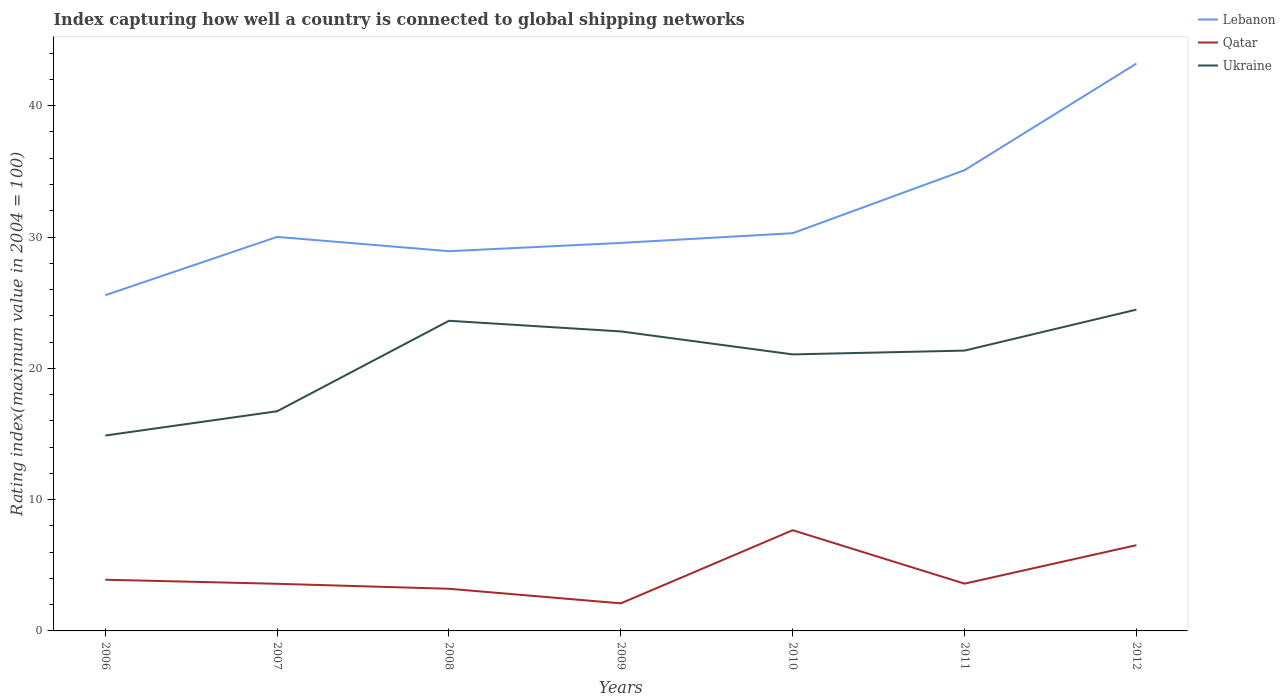How many different coloured lines are there?
Provide a short and direct response. 3. Across all years, what is the maximum rating index in Qatar?
Give a very brief answer. 2.1. What is the total rating index in Ukraine in the graph?
Offer a very short reply. -8.74. What is the difference between the highest and the second highest rating index in Ukraine?
Give a very brief answer. 9.59. How many years are there in the graph?
Your response must be concise. 7. What is the difference between two consecutive major ticks on the Y-axis?
Provide a succinct answer. 10. Are the values on the major ticks of Y-axis written in scientific E-notation?
Offer a terse response. No. How many legend labels are there?
Ensure brevity in your answer.  3. What is the title of the graph?
Give a very brief answer. Index capturing how well a country is connected to global shipping networks. What is the label or title of the Y-axis?
Ensure brevity in your answer.  Rating index(maximum value in 2004 = 100). What is the Rating index(maximum value in 2004 = 100) in Lebanon in 2006?
Offer a terse response. 25.57. What is the Rating index(maximum value in 2004 = 100) of Ukraine in 2006?
Offer a very short reply. 14.88. What is the Rating index(maximum value in 2004 = 100) of Lebanon in 2007?
Provide a succinct answer. 30.01. What is the Rating index(maximum value in 2004 = 100) in Qatar in 2007?
Offer a very short reply. 3.59. What is the Rating index(maximum value in 2004 = 100) of Ukraine in 2007?
Ensure brevity in your answer.  16.73. What is the Rating index(maximum value in 2004 = 100) of Lebanon in 2008?
Give a very brief answer. 28.92. What is the Rating index(maximum value in 2004 = 100) in Qatar in 2008?
Ensure brevity in your answer.  3.21. What is the Rating index(maximum value in 2004 = 100) in Ukraine in 2008?
Offer a very short reply. 23.62. What is the Rating index(maximum value in 2004 = 100) of Lebanon in 2009?
Provide a short and direct response. 29.55. What is the Rating index(maximum value in 2004 = 100) in Ukraine in 2009?
Make the answer very short. 22.81. What is the Rating index(maximum value in 2004 = 100) in Lebanon in 2010?
Give a very brief answer. 30.29. What is the Rating index(maximum value in 2004 = 100) of Qatar in 2010?
Your answer should be very brief. 7.67. What is the Rating index(maximum value in 2004 = 100) in Ukraine in 2010?
Provide a short and direct response. 21.06. What is the Rating index(maximum value in 2004 = 100) in Lebanon in 2011?
Offer a very short reply. 35.09. What is the Rating index(maximum value in 2004 = 100) in Qatar in 2011?
Ensure brevity in your answer.  3.6. What is the Rating index(maximum value in 2004 = 100) of Ukraine in 2011?
Your answer should be very brief. 21.35. What is the Rating index(maximum value in 2004 = 100) in Lebanon in 2012?
Offer a very short reply. 43.21. What is the Rating index(maximum value in 2004 = 100) of Qatar in 2012?
Your answer should be compact. 6.53. What is the Rating index(maximum value in 2004 = 100) in Ukraine in 2012?
Make the answer very short. 24.47. Across all years, what is the maximum Rating index(maximum value in 2004 = 100) in Lebanon?
Your answer should be very brief. 43.21. Across all years, what is the maximum Rating index(maximum value in 2004 = 100) in Qatar?
Your answer should be very brief. 7.67. Across all years, what is the maximum Rating index(maximum value in 2004 = 100) of Ukraine?
Offer a terse response. 24.47. Across all years, what is the minimum Rating index(maximum value in 2004 = 100) in Lebanon?
Keep it short and to the point. 25.57. Across all years, what is the minimum Rating index(maximum value in 2004 = 100) of Ukraine?
Provide a succinct answer. 14.88. What is the total Rating index(maximum value in 2004 = 100) of Lebanon in the graph?
Keep it short and to the point. 222.64. What is the total Rating index(maximum value in 2004 = 100) in Qatar in the graph?
Make the answer very short. 30.6. What is the total Rating index(maximum value in 2004 = 100) in Ukraine in the graph?
Make the answer very short. 144.92. What is the difference between the Rating index(maximum value in 2004 = 100) of Lebanon in 2006 and that in 2007?
Ensure brevity in your answer.  -4.44. What is the difference between the Rating index(maximum value in 2004 = 100) in Qatar in 2006 and that in 2007?
Give a very brief answer. 0.31. What is the difference between the Rating index(maximum value in 2004 = 100) in Ukraine in 2006 and that in 2007?
Offer a very short reply. -1.85. What is the difference between the Rating index(maximum value in 2004 = 100) of Lebanon in 2006 and that in 2008?
Provide a short and direct response. -3.35. What is the difference between the Rating index(maximum value in 2004 = 100) of Qatar in 2006 and that in 2008?
Your answer should be very brief. 0.69. What is the difference between the Rating index(maximum value in 2004 = 100) of Ukraine in 2006 and that in 2008?
Your response must be concise. -8.74. What is the difference between the Rating index(maximum value in 2004 = 100) of Lebanon in 2006 and that in 2009?
Offer a very short reply. -3.98. What is the difference between the Rating index(maximum value in 2004 = 100) in Ukraine in 2006 and that in 2009?
Make the answer very short. -7.93. What is the difference between the Rating index(maximum value in 2004 = 100) of Lebanon in 2006 and that in 2010?
Provide a succinct answer. -4.72. What is the difference between the Rating index(maximum value in 2004 = 100) of Qatar in 2006 and that in 2010?
Provide a short and direct response. -3.77. What is the difference between the Rating index(maximum value in 2004 = 100) of Ukraine in 2006 and that in 2010?
Your answer should be compact. -6.18. What is the difference between the Rating index(maximum value in 2004 = 100) of Lebanon in 2006 and that in 2011?
Make the answer very short. -9.52. What is the difference between the Rating index(maximum value in 2004 = 100) of Ukraine in 2006 and that in 2011?
Give a very brief answer. -6.47. What is the difference between the Rating index(maximum value in 2004 = 100) of Lebanon in 2006 and that in 2012?
Your response must be concise. -17.64. What is the difference between the Rating index(maximum value in 2004 = 100) in Qatar in 2006 and that in 2012?
Your response must be concise. -2.63. What is the difference between the Rating index(maximum value in 2004 = 100) in Ukraine in 2006 and that in 2012?
Your answer should be very brief. -9.59. What is the difference between the Rating index(maximum value in 2004 = 100) in Lebanon in 2007 and that in 2008?
Offer a terse response. 1.09. What is the difference between the Rating index(maximum value in 2004 = 100) of Qatar in 2007 and that in 2008?
Provide a short and direct response. 0.38. What is the difference between the Rating index(maximum value in 2004 = 100) of Ukraine in 2007 and that in 2008?
Your answer should be very brief. -6.89. What is the difference between the Rating index(maximum value in 2004 = 100) of Lebanon in 2007 and that in 2009?
Ensure brevity in your answer.  0.46. What is the difference between the Rating index(maximum value in 2004 = 100) in Qatar in 2007 and that in 2009?
Give a very brief answer. 1.49. What is the difference between the Rating index(maximum value in 2004 = 100) in Ukraine in 2007 and that in 2009?
Your answer should be compact. -6.08. What is the difference between the Rating index(maximum value in 2004 = 100) in Lebanon in 2007 and that in 2010?
Give a very brief answer. -0.28. What is the difference between the Rating index(maximum value in 2004 = 100) of Qatar in 2007 and that in 2010?
Ensure brevity in your answer.  -4.08. What is the difference between the Rating index(maximum value in 2004 = 100) of Ukraine in 2007 and that in 2010?
Provide a succinct answer. -4.33. What is the difference between the Rating index(maximum value in 2004 = 100) in Lebanon in 2007 and that in 2011?
Provide a short and direct response. -5.08. What is the difference between the Rating index(maximum value in 2004 = 100) of Qatar in 2007 and that in 2011?
Keep it short and to the point. -0.01. What is the difference between the Rating index(maximum value in 2004 = 100) in Ukraine in 2007 and that in 2011?
Ensure brevity in your answer.  -4.62. What is the difference between the Rating index(maximum value in 2004 = 100) in Qatar in 2007 and that in 2012?
Give a very brief answer. -2.94. What is the difference between the Rating index(maximum value in 2004 = 100) of Ukraine in 2007 and that in 2012?
Your response must be concise. -7.74. What is the difference between the Rating index(maximum value in 2004 = 100) in Lebanon in 2008 and that in 2009?
Provide a succinct answer. -0.63. What is the difference between the Rating index(maximum value in 2004 = 100) in Qatar in 2008 and that in 2009?
Keep it short and to the point. 1.11. What is the difference between the Rating index(maximum value in 2004 = 100) of Ukraine in 2008 and that in 2009?
Your answer should be very brief. 0.81. What is the difference between the Rating index(maximum value in 2004 = 100) in Lebanon in 2008 and that in 2010?
Offer a very short reply. -1.37. What is the difference between the Rating index(maximum value in 2004 = 100) in Qatar in 2008 and that in 2010?
Provide a succinct answer. -4.46. What is the difference between the Rating index(maximum value in 2004 = 100) in Ukraine in 2008 and that in 2010?
Ensure brevity in your answer.  2.56. What is the difference between the Rating index(maximum value in 2004 = 100) of Lebanon in 2008 and that in 2011?
Your response must be concise. -6.17. What is the difference between the Rating index(maximum value in 2004 = 100) of Qatar in 2008 and that in 2011?
Your response must be concise. -0.39. What is the difference between the Rating index(maximum value in 2004 = 100) in Ukraine in 2008 and that in 2011?
Provide a succinct answer. 2.27. What is the difference between the Rating index(maximum value in 2004 = 100) in Lebanon in 2008 and that in 2012?
Keep it short and to the point. -14.29. What is the difference between the Rating index(maximum value in 2004 = 100) in Qatar in 2008 and that in 2012?
Offer a terse response. -3.32. What is the difference between the Rating index(maximum value in 2004 = 100) of Ukraine in 2008 and that in 2012?
Offer a very short reply. -0.85. What is the difference between the Rating index(maximum value in 2004 = 100) in Lebanon in 2009 and that in 2010?
Your response must be concise. -0.74. What is the difference between the Rating index(maximum value in 2004 = 100) of Qatar in 2009 and that in 2010?
Your answer should be very brief. -5.57. What is the difference between the Rating index(maximum value in 2004 = 100) in Lebanon in 2009 and that in 2011?
Your answer should be compact. -5.54. What is the difference between the Rating index(maximum value in 2004 = 100) in Qatar in 2009 and that in 2011?
Offer a terse response. -1.5. What is the difference between the Rating index(maximum value in 2004 = 100) in Ukraine in 2009 and that in 2011?
Your answer should be very brief. 1.46. What is the difference between the Rating index(maximum value in 2004 = 100) of Lebanon in 2009 and that in 2012?
Provide a succinct answer. -13.66. What is the difference between the Rating index(maximum value in 2004 = 100) in Qatar in 2009 and that in 2012?
Offer a terse response. -4.43. What is the difference between the Rating index(maximum value in 2004 = 100) of Ukraine in 2009 and that in 2012?
Your answer should be compact. -1.66. What is the difference between the Rating index(maximum value in 2004 = 100) in Qatar in 2010 and that in 2011?
Provide a short and direct response. 4.07. What is the difference between the Rating index(maximum value in 2004 = 100) of Ukraine in 2010 and that in 2011?
Ensure brevity in your answer.  -0.29. What is the difference between the Rating index(maximum value in 2004 = 100) in Lebanon in 2010 and that in 2012?
Make the answer very short. -12.92. What is the difference between the Rating index(maximum value in 2004 = 100) of Qatar in 2010 and that in 2012?
Make the answer very short. 1.14. What is the difference between the Rating index(maximum value in 2004 = 100) in Ukraine in 2010 and that in 2012?
Provide a succinct answer. -3.41. What is the difference between the Rating index(maximum value in 2004 = 100) of Lebanon in 2011 and that in 2012?
Provide a short and direct response. -8.12. What is the difference between the Rating index(maximum value in 2004 = 100) of Qatar in 2011 and that in 2012?
Your answer should be compact. -2.93. What is the difference between the Rating index(maximum value in 2004 = 100) in Ukraine in 2011 and that in 2012?
Ensure brevity in your answer.  -3.12. What is the difference between the Rating index(maximum value in 2004 = 100) of Lebanon in 2006 and the Rating index(maximum value in 2004 = 100) of Qatar in 2007?
Offer a very short reply. 21.98. What is the difference between the Rating index(maximum value in 2004 = 100) of Lebanon in 2006 and the Rating index(maximum value in 2004 = 100) of Ukraine in 2007?
Provide a short and direct response. 8.84. What is the difference between the Rating index(maximum value in 2004 = 100) in Qatar in 2006 and the Rating index(maximum value in 2004 = 100) in Ukraine in 2007?
Ensure brevity in your answer.  -12.83. What is the difference between the Rating index(maximum value in 2004 = 100) in Lebanon in 2006 and the Rating index(maximum value in 2004 = 100) in Qatar in 2008?
Your answer should be compact. 22.36. What is the difference between the Rating index(maximum value in 2004 = 100) of Lebanon in 2006 and the Rating index(maximum value in 2004 = 100) of Ukraine in 2008?
Your response must be concise. 1.95. What is the difference between the Rating index(maximum value in 2004 = 100) of Qatar in 2006 and the Rating index(maximum value in 2004 = 100) of Ukraine in 2008?
Your answer should be very brief. -19.72. What is the difference between the Rating index(maximum value in 2004 = 100) in Lebanon in 2006 and the Rating index(maximum value in 2004 = 100) in Qatar in 2009?
Keep it short and to the point. 23.47. What is the difference between the Rating index(maximum value in 2004 = 100) in Lebanon in 2006 and the Rating index(maximum value in 2004 = 100) in Ukraine in 2009?
Your response must be concise. 2.76. What is the difference between the Rating index(maximum value in 2004 = 100) in Qatar in 2006 and the Rating index(maximum value in 2004 = 100) in Ukraine in 2009?
Your answer should be compact. -18.91. What is the difference between the Rating index(maximum value in 2004 = 100) of Lebanon in 2006 and the Rating index(maximum value in 2004 = 100) of Ukraine in 2010?
Your answer should be very brief. 4.51. What is the difference between the Rating index(maximum value in 2004 = 100) of Qatar in 2006 and the Rating index(maximum value in 2004 = 100) of Ukraine in 2010?
Provide a short and direct response. -17.16. What is the difference between the Rating index(maximum value in 2004 = 100) in Lebanon in 2006 and the Rating index(maximum value in 2004 = 100) in Qatar in 2011?
Offer a very short reply. 21.97. What is the difference between the Rating index(maximum value in 2004 = 100) of Lebanon in 2006 and the Rating index(maximum value in 2004 = 100) of Ukraine in 2011?
Provide a succinct answer. 4.22. What is the difference between the Rating index(maximum value in 2004 = 100) of Qatar in 2006 and the Rating index(maximum value in 2004 = 100) of Ukraine in 2011?
Give a very brief answer. -17.45. What is the difference between the Rating index(maximum value in 2004 = 100) of Lebanon in 2006 and the Rating index(maximum value in 2004 = 100) of Qatar in 2012?
Your response must be concise. 19.04. What is the difference between the Rating index(maximum value in 2004 = 100) in Qatar in 2006 and the Rating index(maximum value in 2004 = 100) in Ukraine in 2012?
Your answer should be compact. -20.57. What is the difference between the Rating index(maximum value in 2004 = 100) in Lebanon in 2007 and the Rating index(maximum value in 2004 = 100) in Qatar in 2008?
Give a very brief answer. 26.8. What is the difference between the Rating index(maximum value in 2004 = 100) in Lebanon in 2007 and the Rating index(maximum value in 2004 = 100) in Ukraine in 2008?
Make the answer very short. 6.39. What is the difference between the Rating index(maximum value in 2004 = 100) in Qatar in 2007 and the Rating index(maximum value in 2004 = 100) in Ukraine in 2008?
Your answer should be very brief. -20.03. What is the difference between the Rating index(maximum value in 2004 = 100) of Lebanon in 2007 and the Rating index(maximum value in 2004 = 100) of Qatar in 2009?
Make the answer very short. 27.91. What is the difference between the Rating index(maximum value in 2004 = 100) in Qatar in 2007 and the Rating index(maximum value in 2004 = 100) in Ukraine in 2009?
Your answer should be compact. -19.22. What is the difference between the Rating index(maximum value in 2004 = 100) of Lebanon in 2007 and the Rating index(maximum value in 2004 = 100) of Qatar in 2010?
Your answer should be very brief. 22.34. What is the difference between the Rating index(maximum value in 2004 = 100) of Lebanon in 2007 and the Rating index(maximum value in 2004 = 100) of Ukraine in 2010?
Your response must be concise. 8.95. What is the difference between the Rating index(maximum value in 2004 = 100) in Qatar in 2007 and the Rating index(maximum value in 2004 = 100) in Ukraine in 2010?
Make the answer very short. -17.47. What is the difference between the Rating index(maximum value in 2004 = 100) of Lebanon in 2007 and the Rating index(maximum value in 2004 = 100) of Qatar in 2011?
Ensure brevity in your answer.  26.41. What is the difference between the Rating index(maximum value in 2004 = 100) of Lebanon in 2007 and the Rating index(maximum value in 2004 = 100) of Ukraine in 2011?
Provide a short and direct response. 8.66. What is the difference between the Rating index(maximum value in 2004 = 100) of Qatar in 2007 and the Rating index(maximum value in 2004 = 100) of Ukraine in 2011?
Give a very brief answer. -17.76. What is the difference between the Rating index(maximum value in 2004 = 100) of Lebanon in 2007 and the Rating index(maximum value in 2004 = 100) of Qatar in 2012?
Ensure brevity in your answer.  23.48. What is the difference between the Rating index(maximum value in 2004 = 100) in Lebanon in 2007 and the Rating index(maximum value in 2004 = 100) in Ukraine in 2012?
Your answer should be very brief. 5.54. What is the difference between the Rating index(maximum value in 2004 = 100) in Qatar in 2007 and the Rating index(maximum value in 2004 = 100) in Ukraine in 2012?
Offer a very short reply. -20.88. What is the difference between the Rating index(maximum value in 2004 = 100) in Lebanon in 2008 and the Rating index(maximum value in 2004 = 100) in Qatar in 2009?
Ensure brevity in your answer.  26.82. What is the difference between the Rating index(maximum value in 2004 = 100) of Lebanon in 2008 and the Rating index(maximum value in 2004 = 100) of Ukraine in 2009?
Give a very brief answer. 6.11. What is the difference between the Rating index(maximum value in 2004 = 100) of Qatar in 2008 and the Rating index(maximum value in 2004 = 100) of Ukraine in 2009?
Your answer should be very brief. -19.6. What is the difference between the Rating index(maximum value in 2004 = 100) of Lebanon in 2008 and the Rating index(maximum value in 2004 = 100) of Qatar in 2010?
Your response must be concise. 21.25. What is the difference between the Rating index(maximum value in 2004 = 100) in Lebanon in 2008 and the Rating index(maximum value in 2004 = 100) in Ukraine in 2010?
Provide a succinct answer. 7.86. What is the difference between the Rating index(maximum value in 2004 = 100) in Qatar in 2008 and the Rating index(maximum value in 2004 = 100) in Ukraine in 2010?
Keep it short and to the point. -17.85. What is the difference between the Rating index(maximum value in 2004 = 100) in Lebanon in 2008 and the Rating index(maximum value in 2004 = 100) in Qatar in 2011?
Offer a very short reply. 25.32. What is the difference between the Rating index(maximum value in 2004 = 100) in Lebanon in 2008 and the Rating index(maximum value in 2004 = 100) in Ukraine in 2011?
Provide a succinct answer. 7.57. What is the difference between the Rating index(maximum value in 2004 = 100) in Qatar in 2008 and the Rating index(maximum value in 2004 = 100) in Ukraine in 2011?
Offer a very short reply. -18.14. What is the difference between the Rating index(maximum value in 2004 = 100) of Lebanon in 2008 and the Rating index(maximum value in 2004 = 100) of Qatar in 2012?
Make the answer very short. 22.39. What is the difference between the Rating index(maximum value in 2004 = 100) of Lebanon in 2008 and the Rating index(maximum value in 2004 = 100) of Ukraine in 2012?
Your answer should be compact. 4.45. What is the difference between the Rating index(maximum value in 2004 = 100) in Qatar in 2008 and the Rating index(maximum value in 2004 = 100) in Ukraine in 2012?
Make the answer very short. -21.26. What is the difference between the Rating index(maximum value in 2004 = 100) in Lebanon in 2009 and the Rating index(maximum value in 2004 = 100) in Qatar in 2010?
Give a very brief answer. 21.88. What is the difference between the Rating index(maximum value in 2004 = 100) in Lebanon in 2009 and the Rating index(maximum value in 2004 = 100) in Ukraine in 2010?
Provide a succinct answer. 8.49. What is the difference between the Rating index(maximum value in 2004 = 100) in Qatar in 2009 and the Rating index(maximum value in 2004 = 100) in Ukraine in 2010?
Your answer should be very brief. -18.96. What is the difference between the Rating index(maximum value in 2004 = 100) in Lebanon in 2009 and the Rating index(maximum value in 2004 = 100) in Qatar in 2011?
Keep it short and to the point. 25.95. What is the difference between the Rating index(maximum value in 2004 = 100) in Qatar in 2009 and the Rating index(maximum value in 2004 = 100) in Ukraine in 2011?
Ensure brevity in your answer.  -19.25. What is the difference between the Rating index(maximum value in 2004 = 100) in Lebanon in 2009 and the Rating index(maximum value in 2004 = 100) in Qatar in 2012?
Offer a very short reply. 23.02. What is the difference between the Rating index(maximum value in 2004 = 100) in Lebanon in 2009 and the Rating index(maximum value in 2004 = 100) in Ukraine in 2012?
Your answer should be very brief. 5.08. What is the difference between the Rating index(maximum value in 2004 = 100) in Qatar in 2009 and the Rating index(maximum value in 2004 = 100) in Ukraine in 2012?
Offer a terse response. -22.37. What is the difference between the Rating index(maximum value in 2004 = 100) in Lebanon in 2010 and the Rating index(maximum value in 2004 = 100) in Qatar in 2011?
Your answer should be very brief. 26.69. What is the difference between the Rating index(maximum value in 2004 = 100) in Lebanon in 2010 and the Rating index(maximum value in 2004 = 100) in Ukraine in 2011?
Give a very brief answer. 8.94. What is the difference between the Rating index(maximum value in 2004 = 100) in Qatar in 2010 and the Rating index(maximum value in 2004 = 100) in Ukraine in 2011?
Provide a short and direct response. -13.68. What is the difference between the Rating index(maximum value in 2004 = 100) in Lebanon in 2010 and the Rating index(maximum value in 2004 = 100) in Qatar in 2012?
Make the answer very short. 23.76. What is the difference between the Rating index(maximum value in 2004 = 100) of Lebanon in 2010 and the Rating index(maximum value in 2004 = 100) of Ukraine in 2012?
Offer a terse response. 5.82. What is the difference between the Rating index(maximum value in 2004 = 100) in Qatar in 2010 and the Rating index(maximum value in 2004 = 100) in Ukraine in 2012?
Offer a very short reply. -16.8. What is the difference between the Rating index(maximum value in 2004 = 100) in Lebanon in 2011 and the Rating index(maximum value in 2004 = 100) in Qatar in 2012?
Provide a succinct answer. 28.56. What is the difference between the Rating index(maximum value in 2004 = 100) in Lebanon in 2011 and the Rating index(maximum value in 2004 = 100) in Ukraine in 2012?
Offer a terse response. 10.62. What is the difference between the Rating index(maximum value in 2004 = 100) of Qatar in 2011 and the Rating index(maximum value in 2004 = 100) of Ukraine in 2012?
Your answer should be compact. -20.87. What is the average Rating index(maximum value in 2004 = 100) in Lebanon per year?
Your answer should be very brief. 31.81. What is the average Rating index(maximum value in 2004 = 100) in Qatar per year?
Keep it short and to the point. 4.37. What is the average Rating index(maximum value in 2004 = 100) of Ukraine per year?
Your answer should be very brief. 20.7. In the year 2006, what is the difference between the Rating index(maximum value in 2004 = 100) of Lebanon and Rating index(maximum value in 2004 = 100) of Qatar?
Make the answer very short. 21.67. In the year 2006, what is the difference between the Rating index(maximum value in 2004 = 100) of Lebanon and Rating index(maximum value in 2004 = 100) of Ukraine?
Your response must be concise. 10.69. In the year 2006, what is the difference between the Rating index(maximum value in 2004 = 100) in Qatar and Rating index(maximum value in 2004 = 100) in Ukraine?
Provide a short and direct response. -10.98. In the year 2007, what is the difference between the Rating index(maximum value in 2004 = 100) in Lebanon and Rating index(maximum value in 2004 = 100) in Qatar?
Provide a short and direct response. 26.42. In the year 2007, what is the difference between the Rating index(maximum value in 2004 = 100) in Lebanon and Rating index(maximum value in 2004 = 100) in Ukraine?
Give a very brief answer. 13.28. In the year 2007, what is the difference between the Rating index(maximum value in 2004 = 100) of Qatar and Rating index(maximum value in 2004 = 100) of Ukraine?
Provide a short and direct response. -13.14. In the year 2008, what is the difference between the Rating index(maximum value in 2004 = 100) in Lebanon and Rating index(maximum value in 2004 = 100) in Qatar?
Ensure brevity in your answer.  25.71. In the year 2008, what is the difference between the Rating index(maximum value in 2004 = 100) of Lebanon and Rating index(maximum value in 2004 = 100) of Ukraine?
Offer a very short reply. 5.3. In the year 2008, what is the difference between the Rating index(maximum value in 2004 = 100) of Qatar and Rating index(maximum value in 2004 = 100) of Ukraine?
Offer a terse response. -20.41. In the year 2009, what is the difference between the Rating index(maximum value in 2004 = 100) of Lebanon and Rating index(maximum value in 2004 = 100) of Qatar?
Offer a terse response. 27.45. In the year 2009, what is the difference between the Rating index(maximum value in 2004 = 100) in Lebanon and Rating index(maximum value in 2004 = 100) in Ukraine?
Provide a short and direct response. 6.74. In the year 2009, what is the difference between the Rating index(maximum value in 2004 = 100) in Qatar and Rating index(maximum value in 2004 = 100) in Ukraine?
Offer a very short reply. -20.71. In the year 2010, what is the difference between the Rating index(maximum value in 2004 = 100) in Lebanon and Rating index(maximum value in 2004 = 100) in Qatar?
Your response must be concise. 22.62. In the year 2010, what is the difference between the Rating index(maximum value in 2004 = 100) in Lebanon and Rating index(maximum value in 2004 = 100) in Ukraine?
Keep it short and to the point. 9.23. In the year 2010, what is the difference between the Rating index(maximum value in 2004 = 100) of Qatar and Rating index(maximum value in 2004 = 100) of Ukraine?
Ensure brevity in your answer.  -13.39. In the year 2011, what is the difference between the Rating index(maximum value in 2004 = 100) of Lebanon and Rating index(maximum value in 2004 = 100) of Qatar?
Provide a short and direct response. 31.49. In the year 2011, what is the difference between the Rating index(maximum value in 2004 = 100) of Lebanon and Rating index(maximum value in 2004 = 100) of Ukraine?
Provide a short and direct response. 13.74. In the year 2011, what is the difference between the Rating index(maximum value in 2004 = 100) in Qatar and Rating index(maximum value in 2004 = 100) in Ukraine?
Provide a short and direct response. -17.75. In the year 2012, what is the difference between the Rating index(maximum value in 2004 = 100) of Lebanon and Rating index(maximum value in 2004 = 100) of Qatar?
Ensure brevity in your answer.  36.68. In the year 2012, what is the difference between the Rating index(maximum value in 2004 = 100) of Lebanon and Rating index(maximum value in 2004 = 100) of Ukraine?
Ensure brevity in your answer.  18.74. In the year 2012, what is the difference between the Rating index(maximum value in 2004 = 100) of Qatar and Rating index(maximum value in 2004 = 100) of Ukraine?
Ensure brevity in your answer.  -17.94. What is the ratio of the Rating index(maximum value in 2004 = 100) in Lebanon in 2006 to that in 2007?
Offer a terse response. 0.85. What is the ratio of the Rating index(maximum value in 2004 = 100) of Qatar in 2006 to that in 2007?
Your response must be concise. 1.09. What is the ratio of the Rating index(maximum value in 2004 = 100) of Ukraine in 2006 to that in 2007?
Your answer should be very brief. 0.89. What is the ratio of the Rating index(maximum value in 2004 = 100) of Lebanon in 2006 to that in 2008?
Keep it short and to the point. 0.88. What is the ratio of the Rating index(maximum value in 2004 = 100) of Qatar in 2006 to that in 2008?
Keep it short and to the point. 1.22. What is the ratio of the Rating index(maximum value in 2004 = 100) of Ukraine in 2006 to that in 2008?
Ensure brevity in your answer.  0.63. What is the ratio of the Rating index(maximum value in 2004 = 100) of Lebanon in 2006 to that in 2009?
Make the answer very short. 0.87. What is the ratio of the Rating index(maximum value in 2004 = 100) in Qatar in 2006 to that in 2009?
Make the answer very short. 1.86. What is the ratio of the Rating index(maximum value in 2004 = 100) in Ukraine in 2006 to that in 2009?
Provide a short and direct response. 0.65. What is the ratio of the Rating index(maximum value in 2004 = 100) in Lebanon in 2006 to that in 2010?
Keep it short and to the point. 0.84. What is the ratio of the Rating index(maximum value in 2004 = 100) of Qatar in 2006 to that in 2010?
Provide a succinct answer. 0.51. What is the ratio of the Rating index(maximum value in 2004 = 100) in Ukraine in 2006 to that in 2010?
Your answer should be compact. 0.71. What is the ratio of the Rating index(maximum value in 2004 = 100) in Lebanon in 2006 to that in 2011?
Provide a succinct answer. 0.73. What is the ratio of the Rating index(maximum value in 2004 = 100) of Ukraine in 2006 to that in 2011?
Keep it short and to the point. 0.7. What is the ratio of the Rating index(maximum value in 2004 = 100) in Lebanon in 2006 to that in 2012?
Make the answer very short. 0.59. What is the ratio of the Rating index(maximum value in 2004 = 100) of Qatar in 2006 to that in 2012?
Your response must be concise. 0.6. What is the ratio of the Rating index(maximum value in 2004 = 100) in Ukraine in 2006 to that in 2012?
Your response must be concise. 0.61. What is the ratio of the Rating index(maximum value in 2004 = 100) in Lebanon in 2007 to that in 2008?
Provide a succinct answer. 1.04. What is the ratio of the Rating index(maximum value in 2004 = 100) of Qatar in 2007 to that in 2008?
Your answer should be very brief. 1.12. What is the ratio of the Rating index(maximum value in 2004 = 100) of Ukraine in 2007 to that in 2008?
Give a very brief answer. 0.71. What is the ratio of the Rating index(maximum value in 2004 = 100) of Lebanon in 2007 to that in 2009?
Your answer should be very brief. 1.02. What is the ratio of the Rating index(maximum value in 2004 = 100) of Qatar in 2007 to that in 2009?
Make the answer very short. 1.71. What is the ratio of the Rating index(maximum value in 2004 = 100) of Ukraine in 2007 to that in 2009?
Your answer should be very brief. 0.73. What is the ratio of the Rating index(maximum value in 2004 = 100) in Qatar in 2007 to that in 2010?
Ensure brevity in your answer.  0.47. What is the ratio of the Rating index(maximum value in 2004 = 100) of Ukraine in 2007 to that in 2010?
Ensure brevity in your answer.  0.79. What is the ratio of the Rating index(maximum value in 2004 = 100) in Lebanon in 2007 to that in 2011?
Provide a short and direct response. 0.86. What is the ratio of the Rating index(maximum value in 2004 = 100) in Ukraine in 2007 to that in 2011?
Offer a terse response. 0.78. What is the ratio of the Rating index(maximum value in 2004 = 100) in Lebanon in 2007 to that in 2012?
Your answer should be compact. 0.69. What is the ratio of the Rating index(maximum value in 2004 = 100) of Qatar in 2007 to that in 2012?
Give a very brief answer. 0.55. What is the ratio of the Rating index(maximum value in 2004 = 100) in Ukraine in 2007 to that in 2012?
Provide a succinct answer. 0.68. What is the ratio of the Rating index(maximum value in 2004 = 100) of Lebanon in 2008 to that in 2009?
Provide a succinct answer. 0.98. What is the ratio of the Rating index(maximum value in 2004 = 100) in Qatar in 2008 to that in 2009?
Provide a short and direct response. 1.53. What is the ratio of the Rating index(maximum value in 2004 = 100) of Ukraine in 2008 to that in 2009?
Offer a terse response. 1.04. What is the ratio of the Rating index(maximum value in 2004 = 100) in Lebanon in 2008 to that in 2010?
Offer a terse response. 0.95. What is the ratio of the Rating index(maximum value in 2004 = 100) of Qatar in 2008 to that in 2010?
Make the answer very short. 0.42. What is the ratio of the Rating index(maximum value in 2004 = 100) in Ukraine in 2008 to that in 2010?
Offer a very short reply. 1.12. What is the ratio of the Rating index(maximum value in 2004 = 100) of Lebanon in 2008 to that in 2011?
Your answer should be very brief. 0.82. What is the ratio of the Rating index(maximum value in 2004 = 100) in Qatar in 2008 to that in 2011?
Give a very brief answer. 0.89. What is the ratio of the Rating index(maximum value in 2004 = 100) in Ukraine in 2008 to that in 2011?
Offer a terse response. 1.11. What is the ratio of the Rating index(maximum value in 2004 = 100) of Lebanon in 2008 to that in 2012?
Offer a terse response. 0.67. What is the ratio of the Rating index(maximum value in 2004 = 100) in Qatar in 2008 to that in 2012?
Provide a succinct answer. 0.49. What is the ratio of the Rating index(maximum value in 2004 = 100) of Ukraine in 2008 to that in 2012?
Offer a very short reply. 0.97. What is the ratio of the Rating index(maximum value in 2004 = 100) of Lebanon in 2009 to that in 2010?
Your response must be concise. 0.98. What is the ratio of the Rating index(maximum value in 2004 = 100) of Qatar in 2009 to that in 2010?
Offer a terse response. 0.27. What is the ratio of the Rating index(maximum value in 2004 = 100) of Ukraine in 2009 to that in 2010?
Your answer should be very brief. 1.08. What is the ratio of the Rating index(maximum value in 2004 = 100) in Lebanon in 2009 to that in 2011?
Provide a succinct answer. 0.84. What is the ratio of the Rating index(maximum value in 2004 = 100) in Qatar in 2009 to that in 2011?
Ensure brevity in your answer.  0.58. What is the ratio of the Rating index(maximum value in 2004 = 100) of Ukraine in 2009 to that in 2011?
Your answer should be very brief. 1.07. What is the ratio of the Rating index(maximum value in 2004 = 100) of Lebanon in 2009 to that in 2012?
Your answer should be very brief. 0.68. What is the ratio of the Rating index(maximum value in 2004 = 100) of Qatar in 2009 to that in 2012?
Provide a short and direct response. 0.32. What is the ratio of the Rating index(maximum value in 2004 = 100) in Ukraine in 2009 to that in 2012?
Offer a very short reply. 0.93. What is the ratio of the Rating index(maximum value in 2004 = 100) of Lebanon in 2010 to that in 2011?
Provide a succinct answer. 0.86. What is the ratio of the Rating index(maximum value in 2004 = 100) of Qatar in 2010 to that in 2011?
Provide a short and direct response. 2.13. What is the ratio of the Rating index(maximum value in 2004 = 100) in Ukraine in 2010 to that in 2011?
Your response must be concise. 0.99. What is the ratio of the Rating index(maximum value in 2004 = 100) of Lebanon in 2010 to that in 2012?
Offer a very short reply. 0.7. What is the ratio of the Rating index(maximum value in 2004 = 100) of Qatar in 2010 to that in 2012?
Provide a short and direct response. 1.17. What is the ratio of the Rating index(maximum value in 2004 = 100) in Ukraine in 2010 to that in 2012?
Your answer should be very brief. 0.86. What is the ratio of the Rating index(maximum value in 2004 = 100) of Lebanon in 2011 to that in 2012?
Offer a terse response. 0.81. What is the ratio of the Rating index(maximum value in 2004 = 100) in Qatar in 2011 to that in 2012?
Provide a succinct answer. 0.55. What is the ratio of the Rating index(maximum value in 2004 = 100) of Ukraine in 2011 to that in 2012?
Provide a short and direct response. 0.87. What is the difference between the highest and the second highest Rating index(maximum value in 2004 = 100) in Lebanon?
Provide a succinct answer. 8.12. What is the difference between the highest and the second highest Rating index(maximum value in 2004 = 100) in Qatar?
Your answer should be very brief. 1.14. What is the difference between the highest and the second highest Rating index(maximum value in 2004 = 100) of Ukraine?
Keep it short and to the point. 0.85. What is the difference between the highest and the lowest Rating index(maximum value in 2004 = 100) of Lebanon?
Ensure brevity in your answer.  17.64. What is the difference between the highest and the lowest Rating index(maximum value in 2004 = 100) of Qatar?
Keep it short and to the point. 5.57. What is the difference between the highest and the lowest Rating index(maximum value in 2004 = 100) of Ukraine?
Keep it short and to the point. 9.59. 